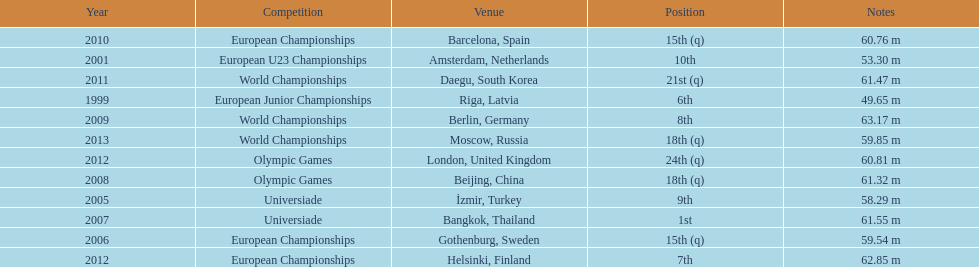What are the years listed prior to 2007? 1999, 2001, 2005, 2006. What are their corresponding finishes? 6th, 10th, 9th, 15th (q). Which is the highest? 6th. 